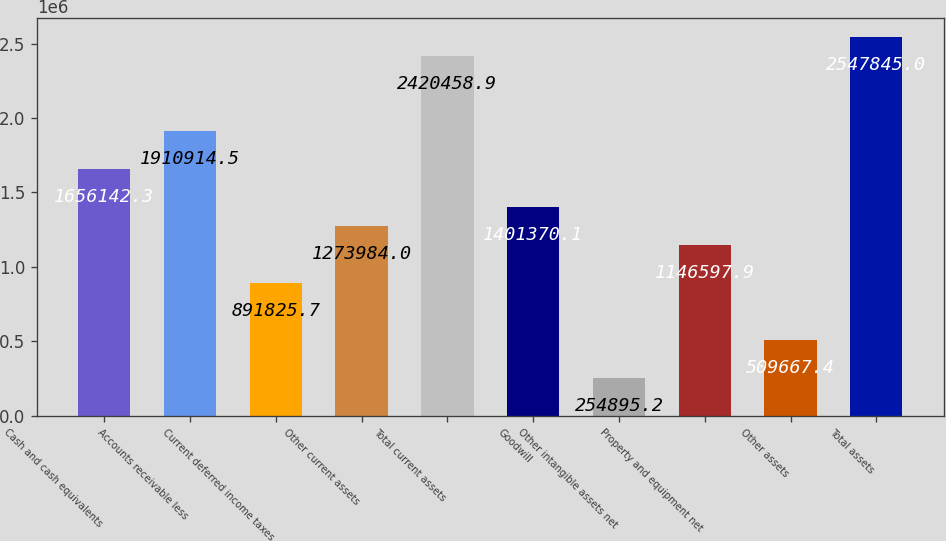Convert chart. <chart><loc_0><loc_0><loc_500><loc_500><bar_chart><fcel>Cash and cash equivalents<fcel>Accounts receivable less<fcel>Current deferred income taxes<fcel>Other current assets<fcel>Total current assets<fcel>Goodwill<fcel>Other intangible assets net<fcel>Property and equipment net<fcel>Other assets<fcel>Total assets<nl><fcel>1.65614e+06<fcel>1.91091e+06<fcel>891826<fcel>1.27398e+06<fcel>2.42046e+06<fcel>1.40137e+06<fcel>254895<fcel>1.1466e+06<fcel>509667<fcel>2.54784e+06<nl></chart> 